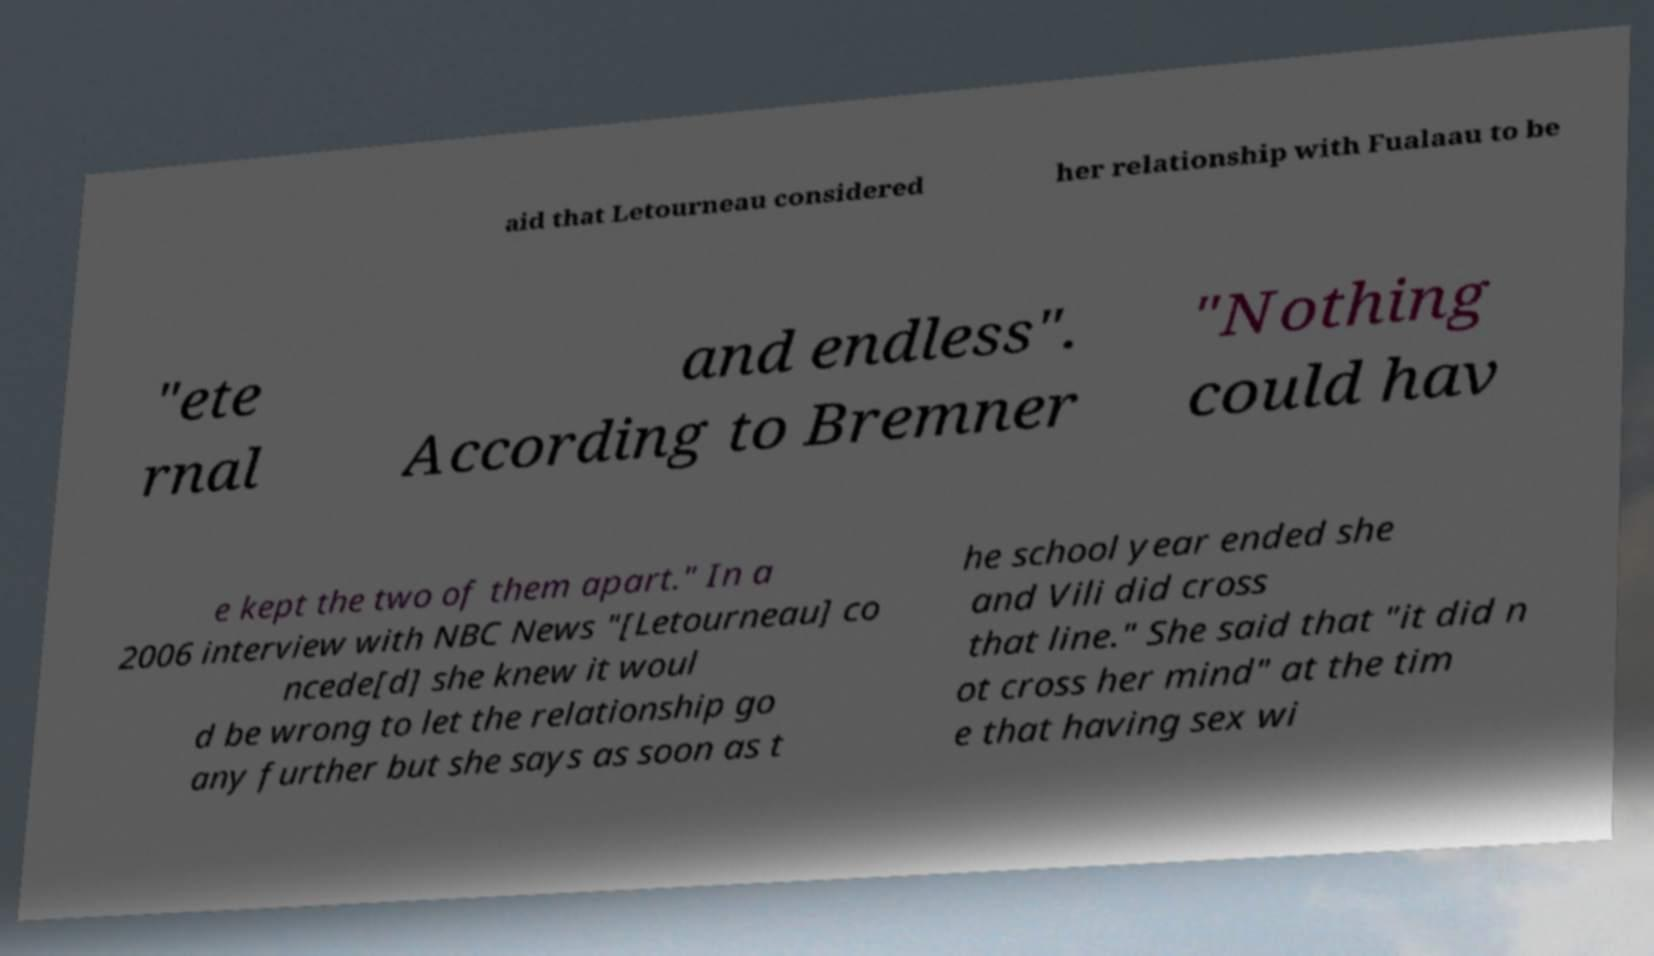Please read and relay the text visible in this image. What does it say? aid that Letourneau considered her relationship with Fualaau to be "ete rnal and endless". According to Bremner "Nothing could hav e kept the two of them apart." In a 2006 interview with NBC News "[Letourneau] co ncede[d] she knew it woul d be wrong to let the relationship go any further but she says as soon as t he school year ended she and Vili did cross that line." She said that "it did n ot cross her mind" at the tim e that having sex wi 